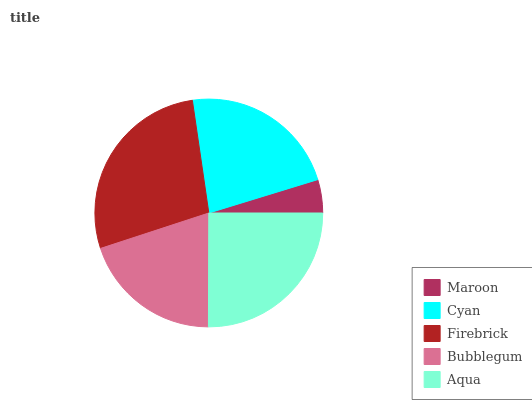Is Maroon the minimum?
Answer yes or no. Yes. Is Firebrick the maximum?
Answer yes or no. Yes. Is Cyan the minimum?
Answer yes or no. No. Is Cyan the maximum?
Answer yes or no. No. Is Cyan greater than Maroon?
Answer yes or no. Yes. Is Maroon less than Cyan?
Answer yes or no. Yes. Is Maroon greater than Cyan?
Answer yes or no. No. Is Cyan less than Maroon?
Answer yes or no. No. Is Cyan the high median?
Answer yes or no. Yes. Is Cyan the low median?
Answer yes or no. Yes. Is Bubblegum the high median?
Answer yes or no. No. Is Maroon the low median?
Answer yes or no. No. 